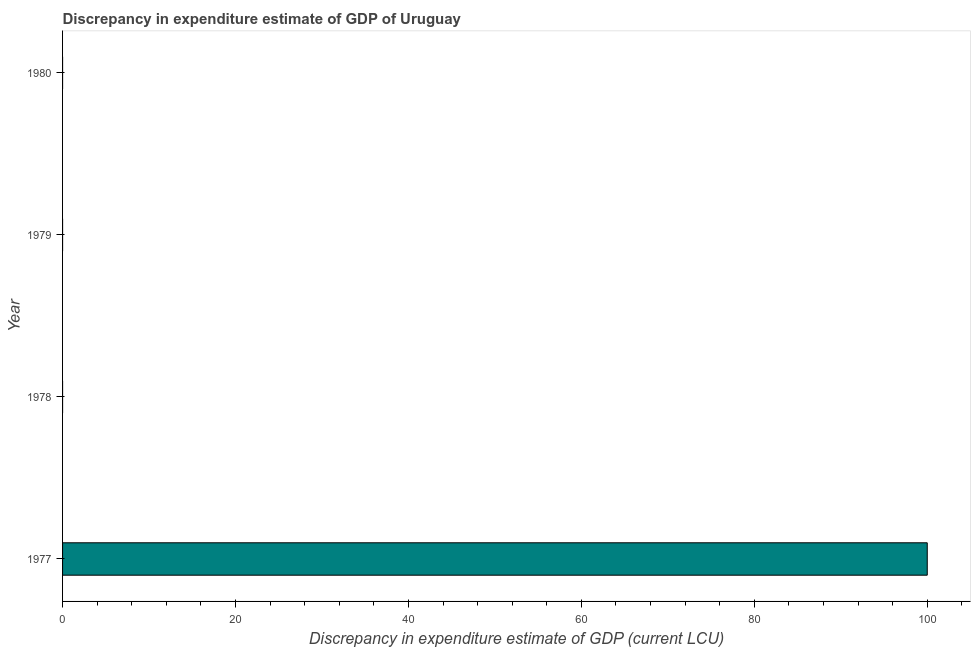Does the graph contain any zero values?
Keep it short and to the point. Yes. What is the title of the graph?
Provide a succinct answer. Discrepancy in expenditure estimate of GDP of Uruguay. What is the label or title of the X-axis?
Ensure brevity in your answer.  Discrepancy in expenditure estimate of GDP (current LCU). What is the discrepancy in expenditure estimate of gdp in 1979?
Offer a terse response. 9e-10. Across all years, what is the maximum discrepancy in expenditure estimate of gdp?
Your response must be concise. 100. In which year was the discrepancy in expenditure estimate of gdp maximum?
Give a very brief answer. 1977. What is the sum of the discrepancy in expenditure estimate of gdp?
Your answer should be very brief. 100. What is the median discrepancy in expenditure estimate of gdp?
Your response must be concise. 4.45e-9. What is the ratio of the discrepancy in expenditure estimate of gdp in 1977 to that in 1978?
Provide a succinct answer. 1.25e+1. Is the discrepancy in expenditure estimate of gdp in 1977 less than that in 1978?
Your response must be concise. No. In how many years, is the discrepancy in expenditure estimate of gdp greater than the average discrepancy in expenditure estimate of gdp taken over all years?
Your answer should be very brief. 1. How many years are there in the graph?
Make the answer very short. 4. Are the values on the major ticks of X-axis written in scientific E-notation?
Your answer should be very brief. No. What is the Discrepancy in expenditure estimate of GDP (current LCU) of 1977?
Your response must be concise. 100. What is the Discrepancy in expenditure estimate of GDP (current LCU) of 1978?
Your answer should be very brief. 8e-9. What is the Discrepancy in expenditure estimate of GDP (current LCU) of 1979?
Make the answer very short. 9e-10. What is the difference between the Discrepancy in expenditure estimate of GDP (current LCU) in 1977 and 1978?
Your answer should be compact. 100. What is the difference between the Discrepancy in expenditure estimate of GDP (current LCU) in 1977 and 1979?
Your answer should be very brief. 100. What is the ratio of the Discrepancy in expenditure estimate of GDP (current LCU) in 1977 to that in 1978?
Keep it short and to the point. 1.25e+1. What is the ratio of the Discrepancy in expenditure estimate of GDP (current LCU) in 1977 to that in 1979?
Your answer should be compact. 1.11e+11. What is the ratio of the Discrepancy in expenditure estimate of GDP (current LCU) in 1978 to that in 1979?
Your response must be concise. 8.89. 